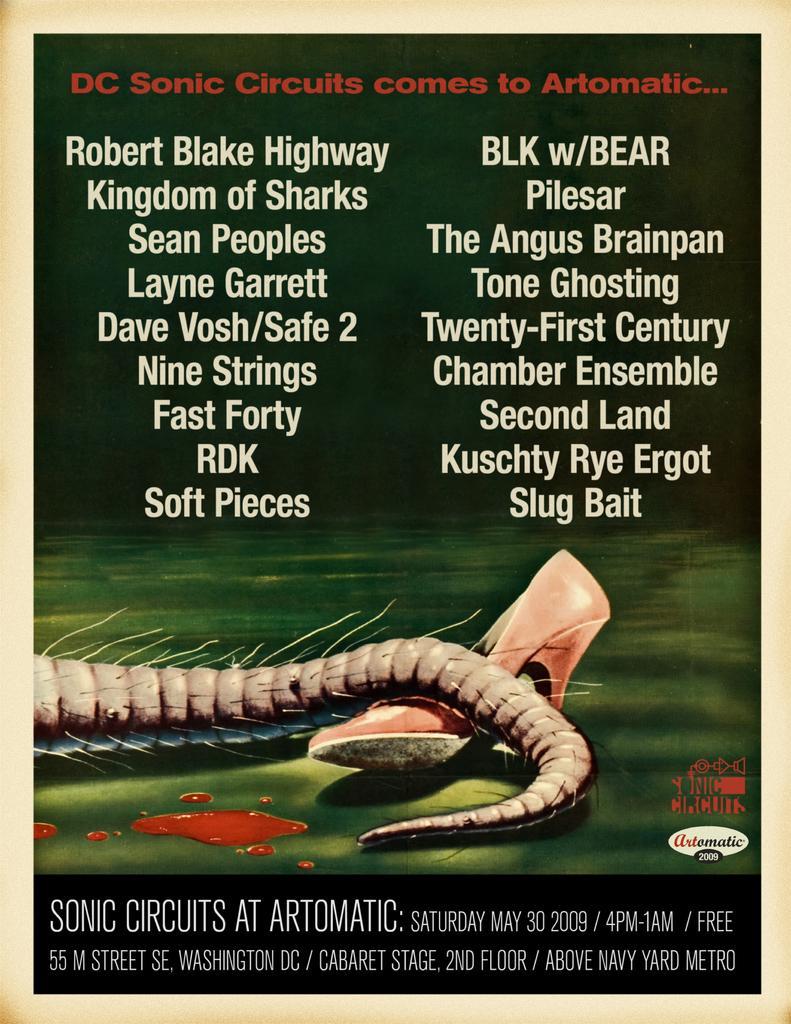How would you summarize this image in a sentence or two? There is a poster. On this poster we can see an animal tail, footwear, and text written on it. 